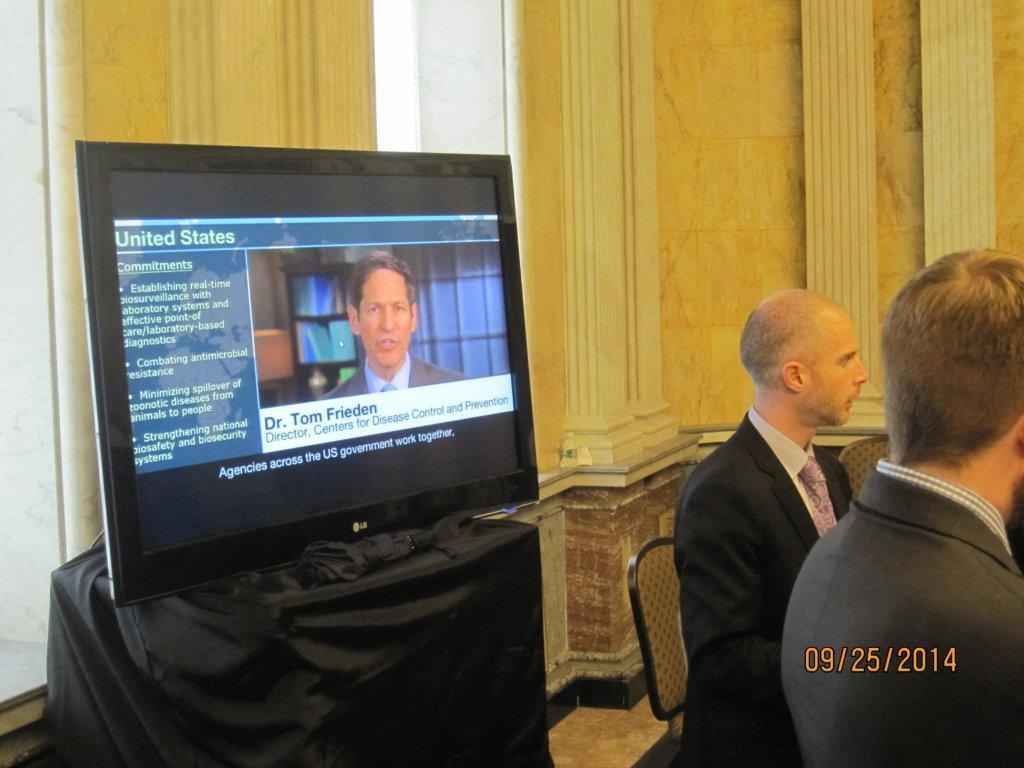Provide a one-sentence caption for the provided image. People sitting at a table while a TV displays Dr. Tom Frieden. 